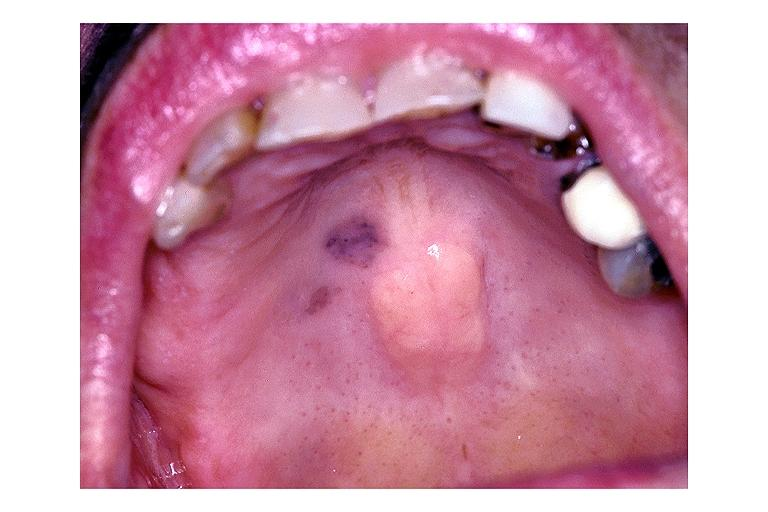s oral present?
Answer the question using a single word or phrase. Yes 